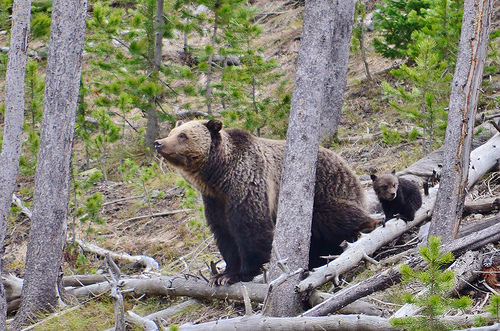<image>
Can you confirm if the tiger is next to the roots? No. The tiger is not positioned next to the roots. They are located in different areas of the scene. Is the bear in front of the tree? No. The bear is not in front of the tree. The spatial positioning shows a different relationship between these objects. 